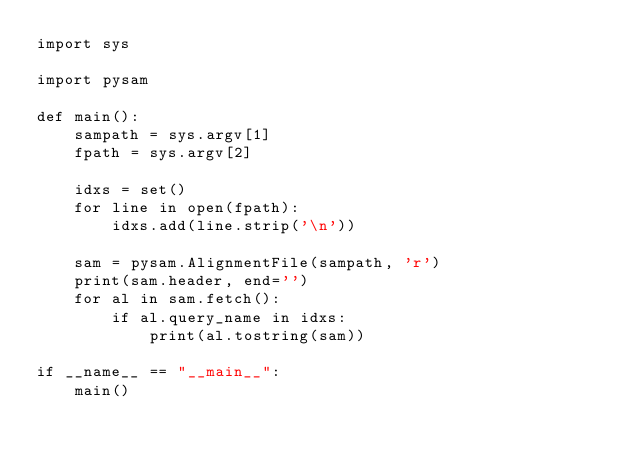Convert code to text. <code><loc_0><loc_0><loc_500><loc_500><_Python_>import sys

import pysam

def main():
    sampath = sys.argv[1]
    fpath = sys.argv[2]

    idxs = set()
    for line in open(fpath):
        idxs.add(line.strip('\n'))

    sam = pysam.AlignmentFile(sampath, 'r')
    print(sam.header, end='')
    for al in sam.fetch():
        if al.query_name in idxs:
            print(al.tostring(sam))

if __name__ == "__main__":
    main()
</code> 